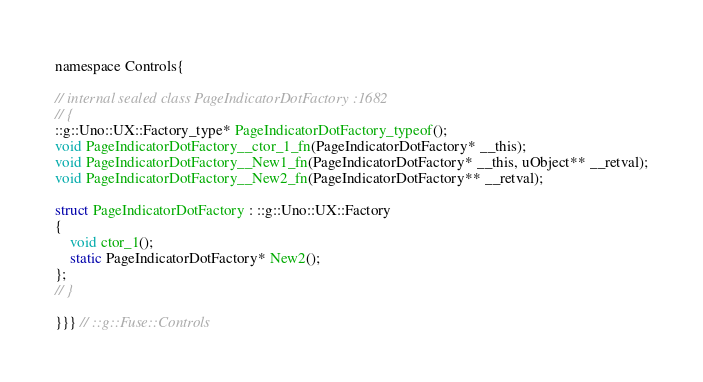<code> <loc_0><loc_0><loc_500><loc_500><_C_>namespace Controls{

// internal sealed class PageIndicatorDotFactory :1682
// {
::g::Uno::UX::Factory_type* PageIndicatorDotFactory_typeof();
void PageIndicatorDotFactory__ctor_1_fn(PageIndicatorDotFactory* __this);
void PageIndicatorDotFactory__New1_fn(PageIndicatorDotFactory* __this, uObject** __retval);
void PageIndicatorDotFactory__New2_fn(PageIndicatorDotFactory** __retval);

struct PageIndicatorDotFactory : ::g::Uno::UX::Factory
{
    void ctor_1();
    static PageIndicatorDotFactory* New2();
};
// }

}}} // ::g::Fuse::Controls
</code> 